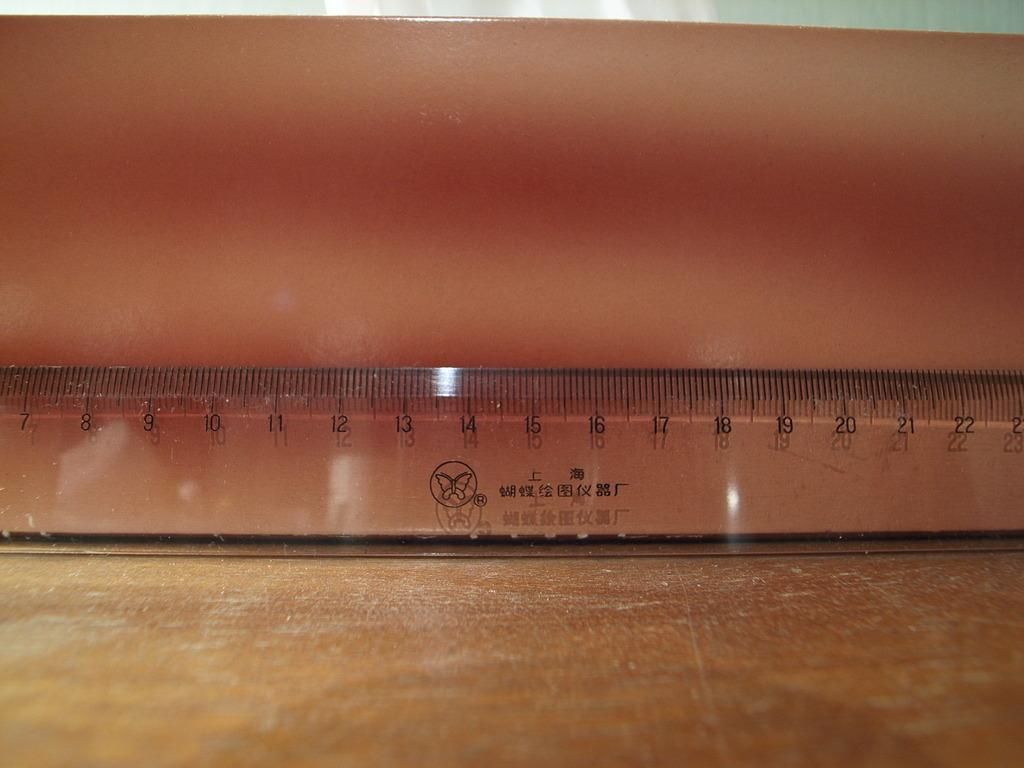<image>
Render a clear and concise summary of the photo. A brown ruler shows measurements from 7 through 22 centimeters. 